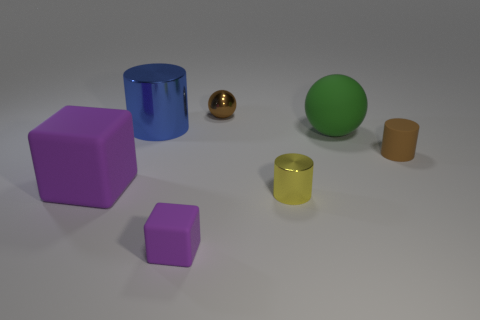Subtract all blue cylinders. Subtract all yellow balls. How many cylinders are left? 2 Add 2 blocks. How many objects exist? 9 Subtract all blocks. How many objects are left? 5 Subtract all purple rubber cubes. Subtract all brown matte cylinders. How many objects are left? 4 Add 3 tiny brown shiny balls. How many tiny brown shiny balls are left? 4 Add 6 yellow things. How many yellow things exist? 7 Subtract 1 green spheres. How many objects are left? 6 